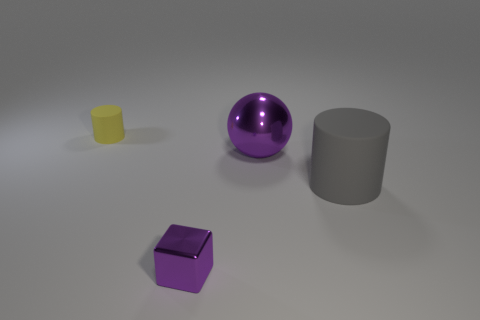Is the material of the yellow thing the same as the purple block? Based on the image, the yellow and purple objects appear to have different materials; the yellow object has a translucent and matte finish, while the purple block exhibits a solid and glossy surface indicating they are made of different substances. 